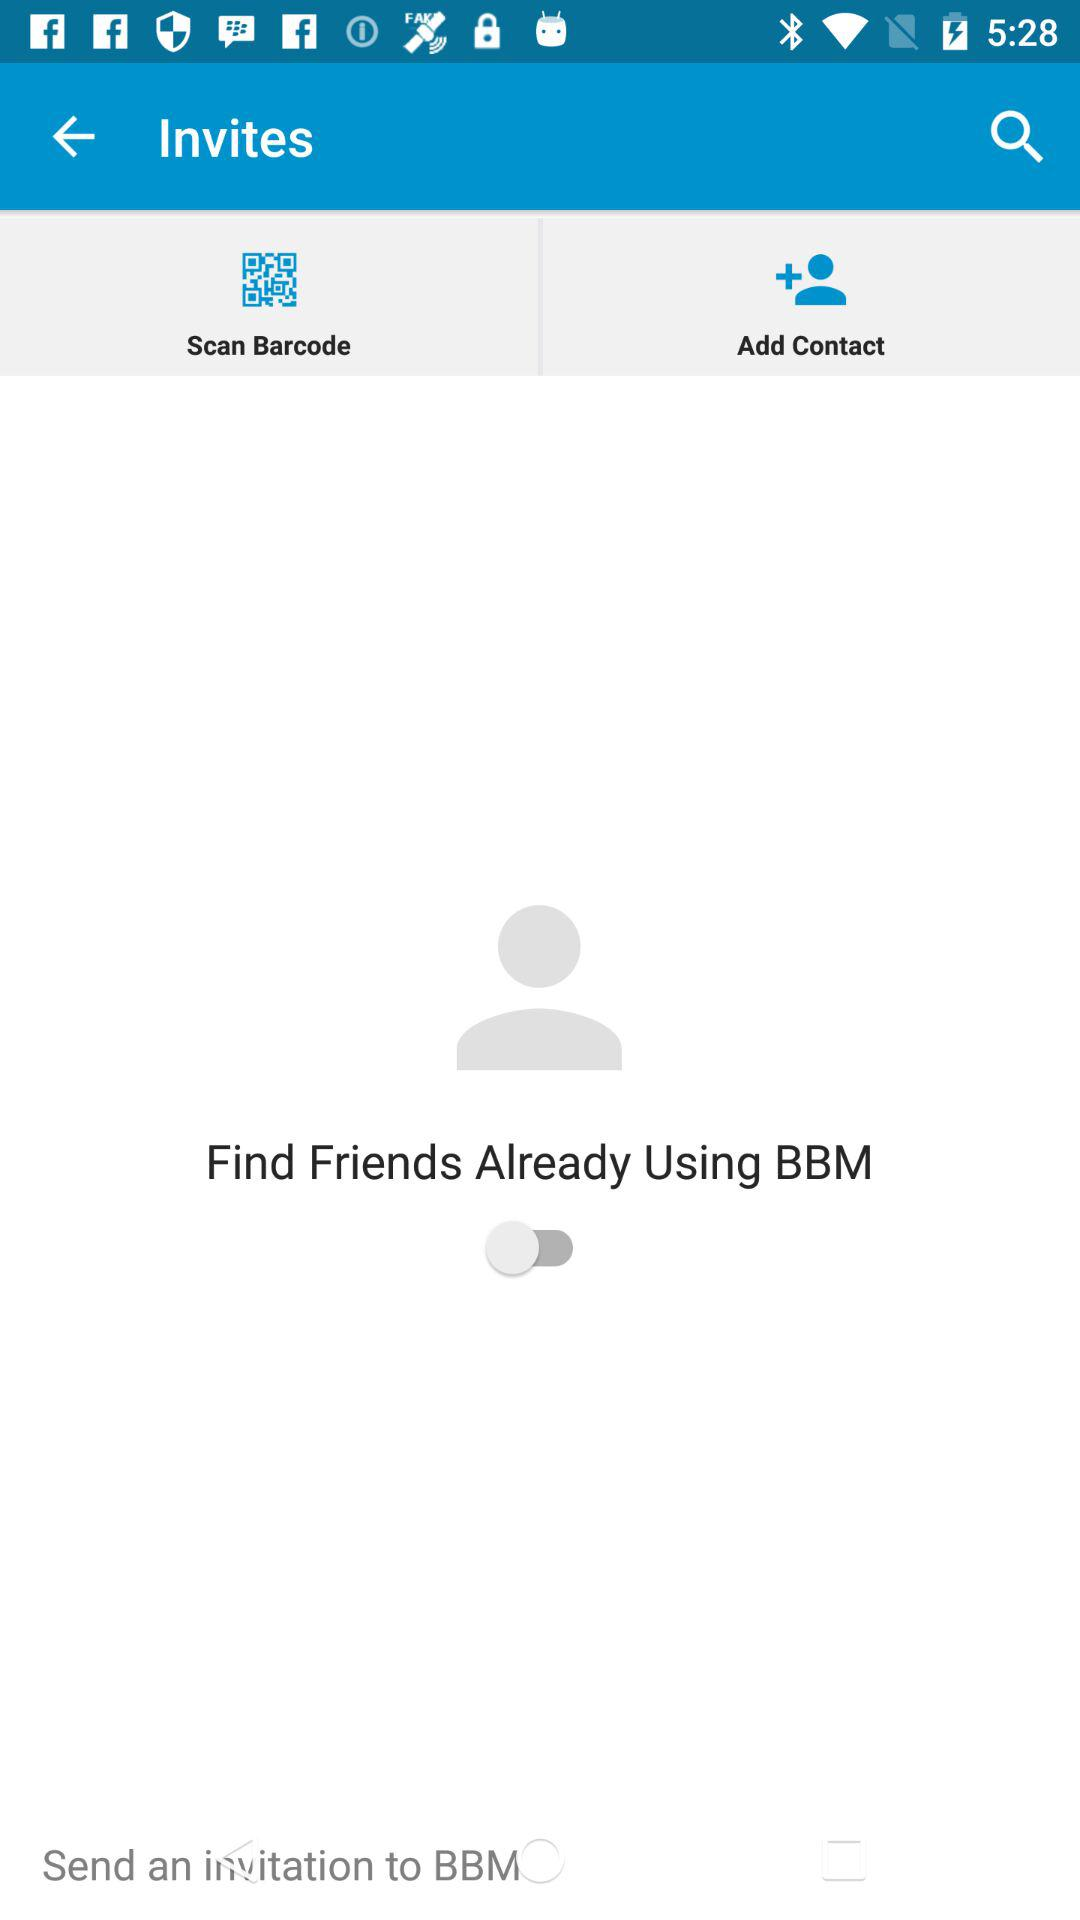What is the status of finding friends already using BBM? The status is "off". 